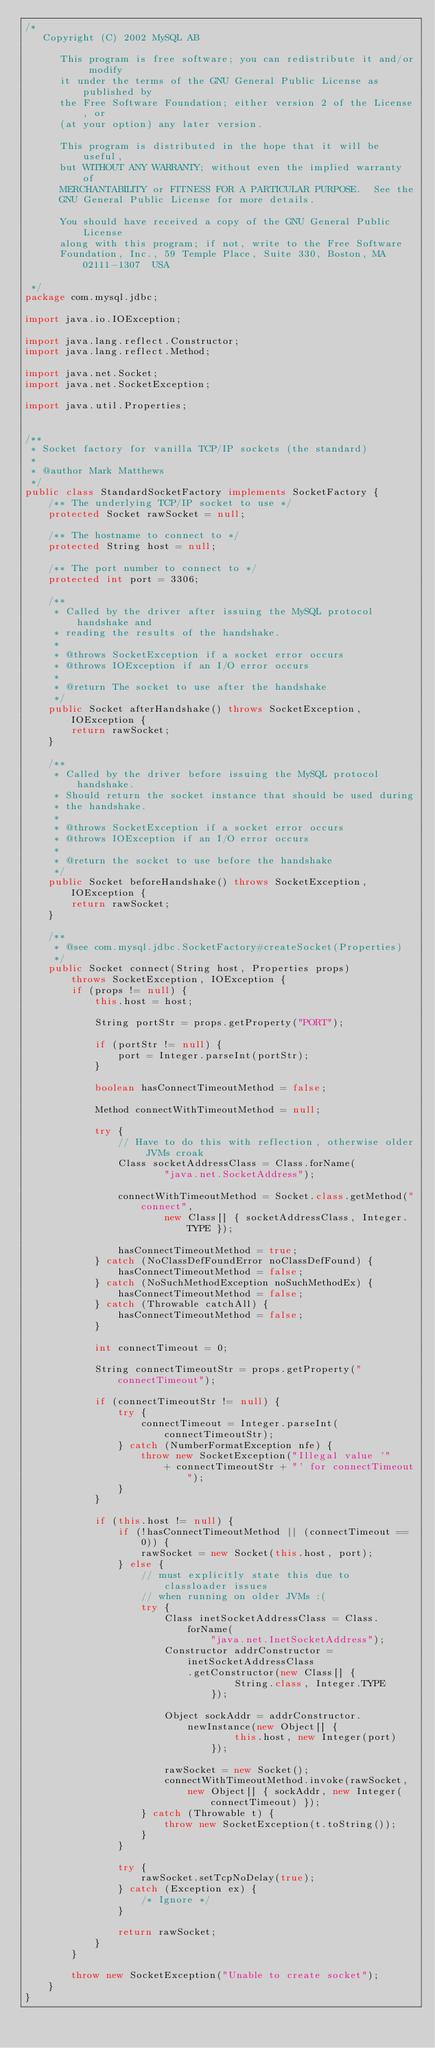Convert code to text. <code><loc_0><loc_0><loc_500><loc_500><_Java_>/*
   Copyright (C) 2002 MySQL AB

      This program is free software; you can redistribute it and/or modify
      it under the terms of the GNU General Public License as published by
      the Free Software Foundation; either version 2 of the License, or
      (at your option) any later version.

      This program is distributed in the hope that it will be useful,
      but WITHOUT ANY WARRANTY; without even the implied warranty of
      MERCHANTABILITY or FITNESS FOR A PARTICULAR PURPOSE.  See the
      GNU General Public License for more details.

      You should have received a copy of the GNU General Public License
      along with this program; if not, write to the Free Software
      Foundation, Inc., 59 Temple Place, Suite 330, Boston, MA  02111-1307  USA

 */
package com.mysql.jdbc;

import java.io.IOException;

import java.lang.reflect.Constructor;
import java.lang.reflect.Method;

import java.net.Socket;
import java.net.SocketException;

import java.util.Properties;


/**
 * Socket factory for vanilla TCP/IP sockets (the standard)
 *
 * @author Mark Matthews
 */
public class StandardSocketFactory implements SocketFactory {
    /** The underlying TCP/IP socket to use */
    protected Socket rawSocket = null;

    /** The hostname to connect to */
    protected String host = null;

    /** The port number to connect to */
    protected int port = 3306;

    /**
     * Called by the driver after issuing the MySQL protocol handshake and
     * reading the results of the handshake.
     *
     * @throws SocketException if a socket error occurs
     * @throws IOException if an I/O error occurs
     *
     * @return The socket to use after the handshake
     */
    public Socket afterHandshake() throws SocketException, IOException {
        return rawSocket;
    }

    /**
     * Called by the driver before issuing the MySQL protocol handshake.
     * Should return the socket instance that should be used during
     * the handshake.
     *
     * @throws SocketException if a socket error occurs
     * @throws IOException if an I/O error occurs
     *
     * @return the socket to use before the handshake
     */
    public Socket beforeHandshake() throws SocketException, IOException {
        return rawSocket;
    }

    /**
     * @see com.mysql.jdbc.SocketFactory#createSocket(Properties)
     */
    public Socket connect(String host, Properties props)
        throws SocketException, IOException {
        if (props != null) {
            this.host = host;

            String portStr = props.getProperty("PORT");

            if (portStr != null) {
                port = Integer.parseInt(portStr);
            }

            boolean hasConnectTimeoutMethod = false;

            Method connectWithTimeoutMethod = null;

            try {
                // Have to do this with reflection, otherwise older JVMs croak
                Class socketAddressClass = Class.forName(
                        "java.net.SocketAddress");

                connectWithTimeoutMethod = Socket.class.getMethod("connect",
                        new Class[] { socketAddressClass, Integer.TYPE });

                hasConnectTimeoutMethod = true;
            } catch (NoClassDefFoundError noClassDefFound) {
                hasConnectTimeoutMethod = false;
            } catch (NoSuchMethodException noSuchMethodEx) {
                hasConnectTimeoutMethod = false;
            } catch (Throwable catchAll) {
                hasConnectTimeoutMethod = false;
            }

            int connectTimeout = 0;

            String connectTimeoutStr = props.getProperty("connectTimeout");

            if (connectTimeoutStr != null) {
                try {
                    connectTimeout = Integer.parseInt(connectTimeoutStr);
                } catch (NumberFormatException nfe) {
                    throw new SocketException("Illegal value '"
                        + connectTimeoutStr + "' for connectTimeout");
                }
            }

            if (this.host != null) {
                if (!hasConnectTimeoutMethod || (connectTimeout == 0)) {
                    rawSocket = new Socket(this.host, port);
                } else {
                    // must explicitly state this due to classloader issues
                    // when running on older JVMs :(
                    try {
                        Class inetSocketAddressClass = Class.forName(
                                "java.net.InetSocketAddress");
                        Constructor addrConstructor = inetSocketAddressClass
                            .getConstructor(new Class[] {
                                    String.class, Integer.TYPE
                                });

                        Object sockAddr = addrConstructor.newInstance(new Object[] {
                                    this.host, new Integer(port)
                                });

                        rawSocket = new Socket();
                        connectWithTimeoutMethod.invoke(rawSocket,
                            new Object[] { sockAddr, new Integer(connectTimeout) });
                    } catch (Throwable t) {
                        throw new SocketException(t.toString());
                    }
                }

                try {
                    rawSocket.setTcpNoDelay(true);
                } catch (Exception ex) {
                    /* Ignore */
                }

                return rawSocket;
            }
        }

        throw new SocketException("Unable to create socket");
    }
}
</code> 